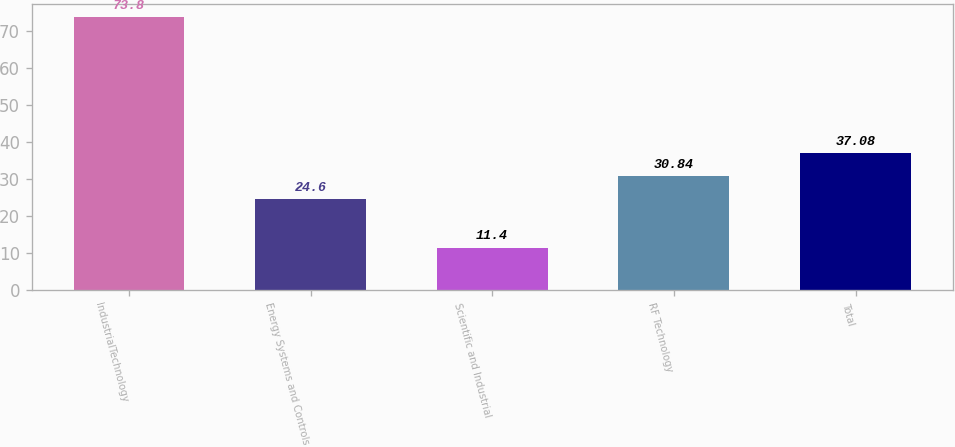Convert chart to OTSL. <chart><loc_0><loc_0><loc_500><loc_500><bar_chart><fcel>IndustrialTechnology<fcel>Energy Systems and Controls<fcel>Scientific and Industrial<fcel>RF Technology<fcel>Total<nl><fcel>73.8<fcel>24.6<fcel>11.4<fcel>30.84<fcel>37.08<nl></chart> 